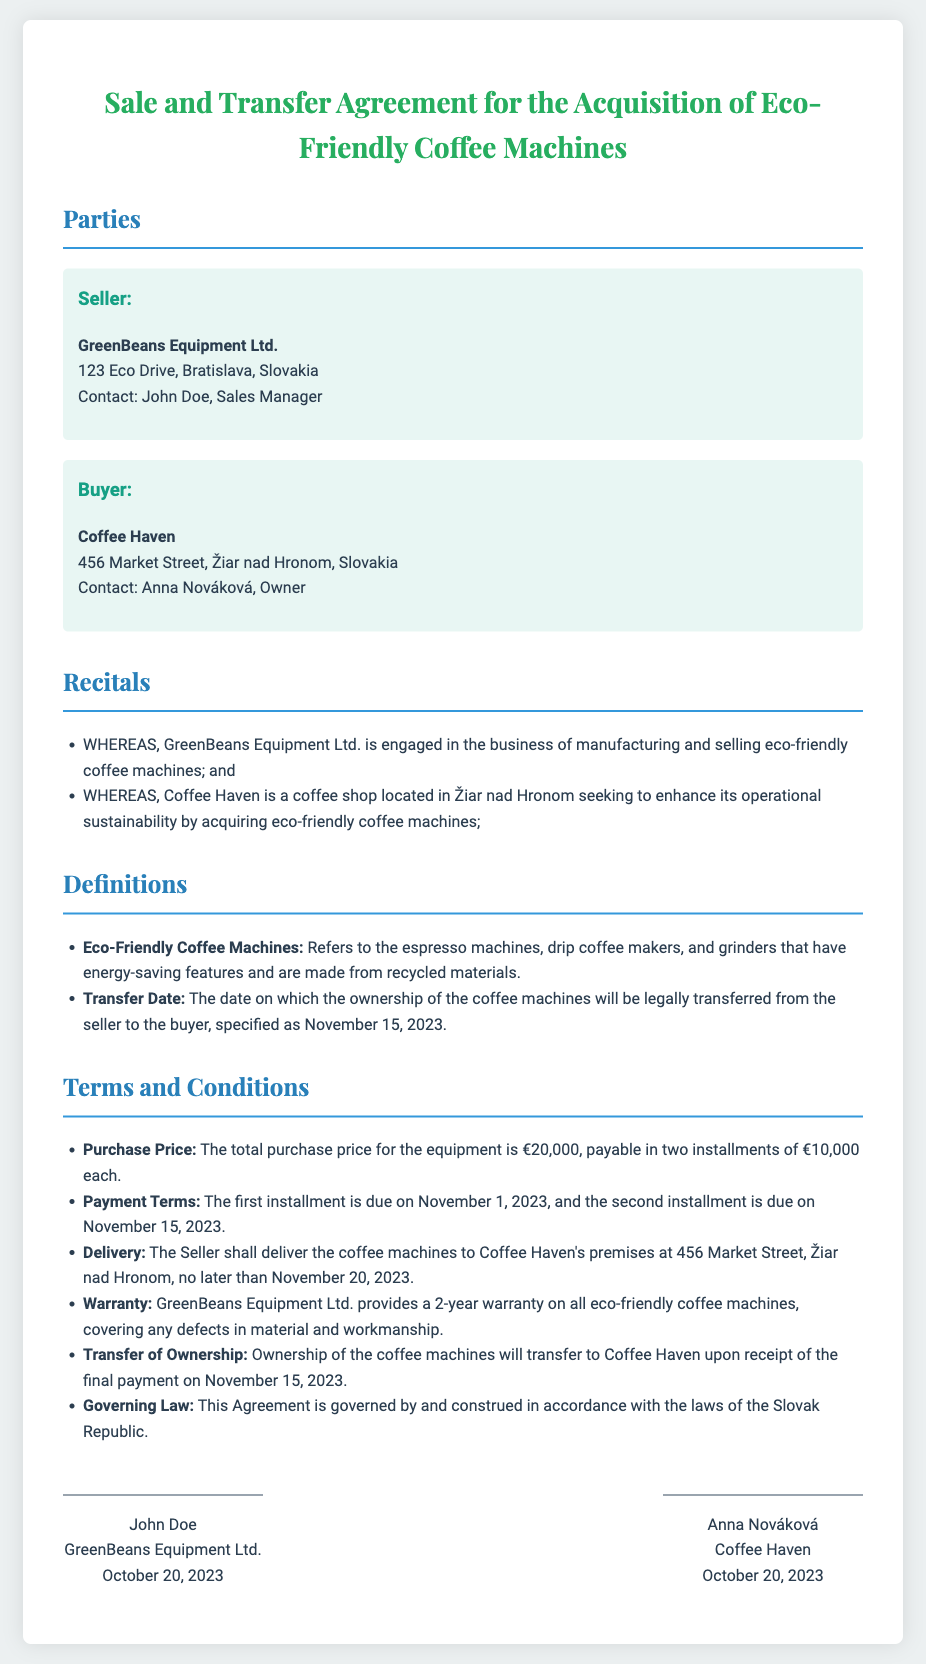What is the name of the seller? The seller is identified in the document as GreenBeans Equipment Ltd.
Answer: GreenBeans Equipment Ltd Who is the buyer's contact person? The contact person for the buyer, specified in the document, is Anna Nováková.
Answer: Anna Nováková What is the purchase price of the coffee machines? The total purchase price for the coffee machines is explicitly stated in the document as €20,000.
Answer: €20,000 When is the first installment due? The document specifies that the first installment of €10,000 is due on November 1, 2023.
Answer: November 1, 2023 What is the warranty period for the coffee machines? The warranty provided by the seller, as detailed in the document, is for a duration of 2 years.
Answer: 2 years What date will ownership transfer to Coffee Haven? The document states that ownership will transfer on the specified date of November 15, 2023.
Answer: November 15, 2023 Where will the coffee machines be delivered? The delivery location for the machines, mentioned in the document, is Coffee Haven's premises at 456 Market Street, Žiar nad Hronom.
Answer: 456 Market Street, Žiar nad Hronom Which law governs this agreement? The document explicitly states that the governing law is that of the Slovak Republic.
Answer: Slovak Republic What type of coffee machines are being acquired? The document clarifies that the acquisition is for eco-friendly coffee machines, which include different types of equipment.
Answer: Eco-Friendly Coffee Machines 